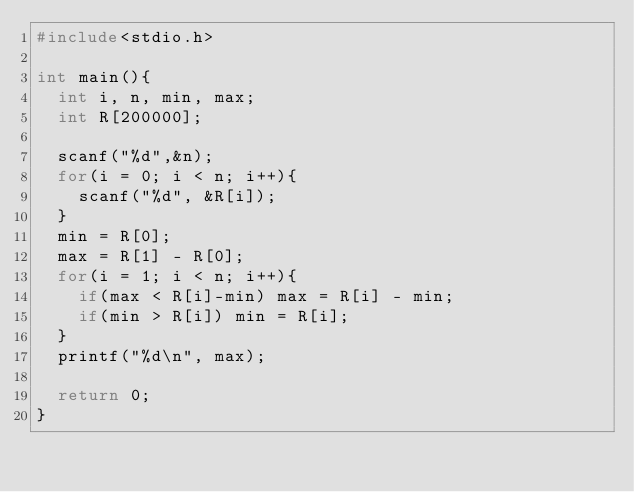Convert code to text. <code><loc_0><loc_0><loc_500><loc_500><_C_>#include<stdio.h>

int main(){
  int i, n, min, max;
  int R[200000];

  scanf("%d",&n);
  for(i = 0; i < n; i++){
    scanf("%d", &R[i]);
  }
  min = R[0];
  max = R[1] - R[0];
  for(i = 1; i < n; i++){
    if(max < R[i]-min) max = R[i] - min;
    if(min > R[i]) min = R[i];
  }
  printf("%d\n", max);

  return 0;
}

</code> 